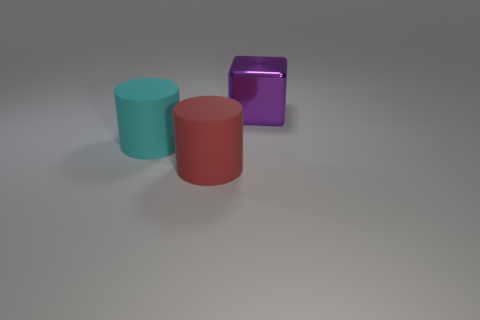There is another matte thing that is the same shape as the red rubber thing; what color is it?
Provide a short and direct response. Cyan. Are there any other things that have the same shape as the red thing?
Provide a succinct answer. Yes. Does the rubber thing that is on the right side of the cyan matte cylinder have the same shape as the matte thing that is to the left of the big red cylinder?
Your response must be concise. Yes. Is the number of big purple cubes greater than the number of things?
Provide a succinct answer. No. Is the cylinder on the left side of the red cylinder made of the same material as the large red cylinder in front of the cyan matte object?
Provide a short and direct response. Yes. What material is the purple object?
Your answer should be very brief. Metal. Are there more cyan things to the left of the red thing than tiny cyan metallic objects?
Keep it short and to the point. Yes. There is a large purple metal object that is on the right side of the rubber cylinder that is to the right of the big cyan matte thing; how many purple metallic things are to the right of it?
Provide a succinct answer. 0. There is a object that is right of the big cyan thing and behind the red thing; what material is it made of?
Keep it short and to the point. Metal. What is the color of the metallic object?
Your response must be concise. Purple. 